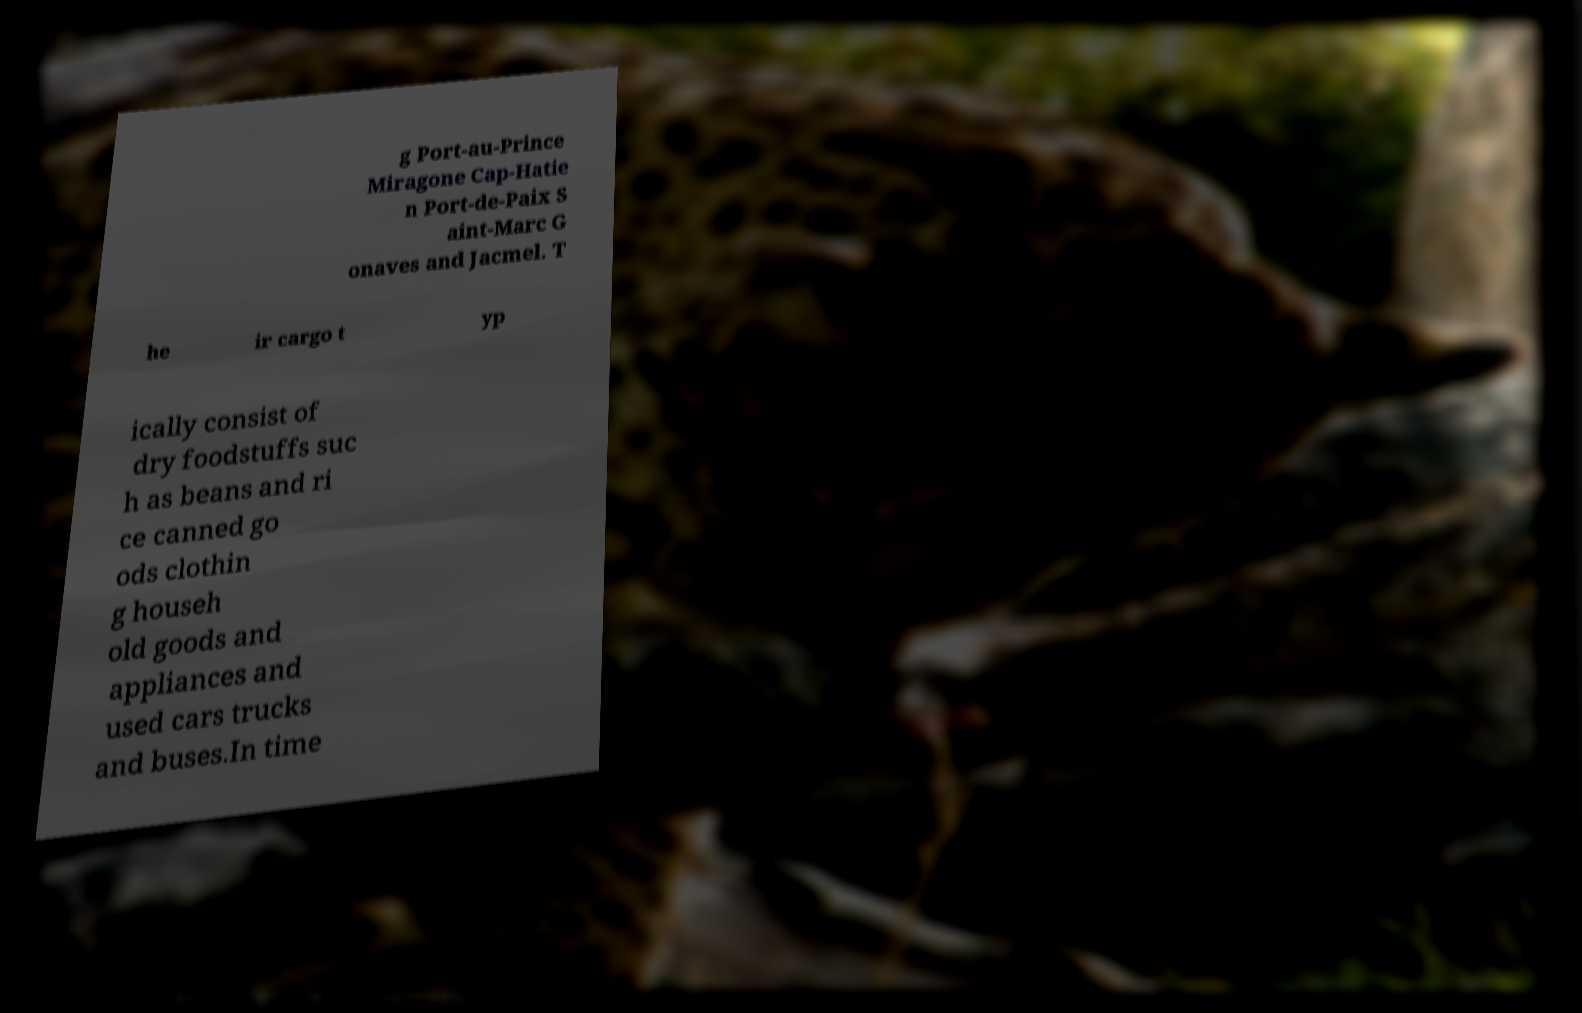Could you extract and type out the text from this image? g Port-au-Prince Miragone Cap-Hatie n Port-de-Paix S aint-Marc G onaves and Jacmel. T he ir cargo t yp ically consist of dry foodstuffs suc h as beans and ri ce canned go ods clothin g househ old goods and appliances and used cars trucks and buses.In time 